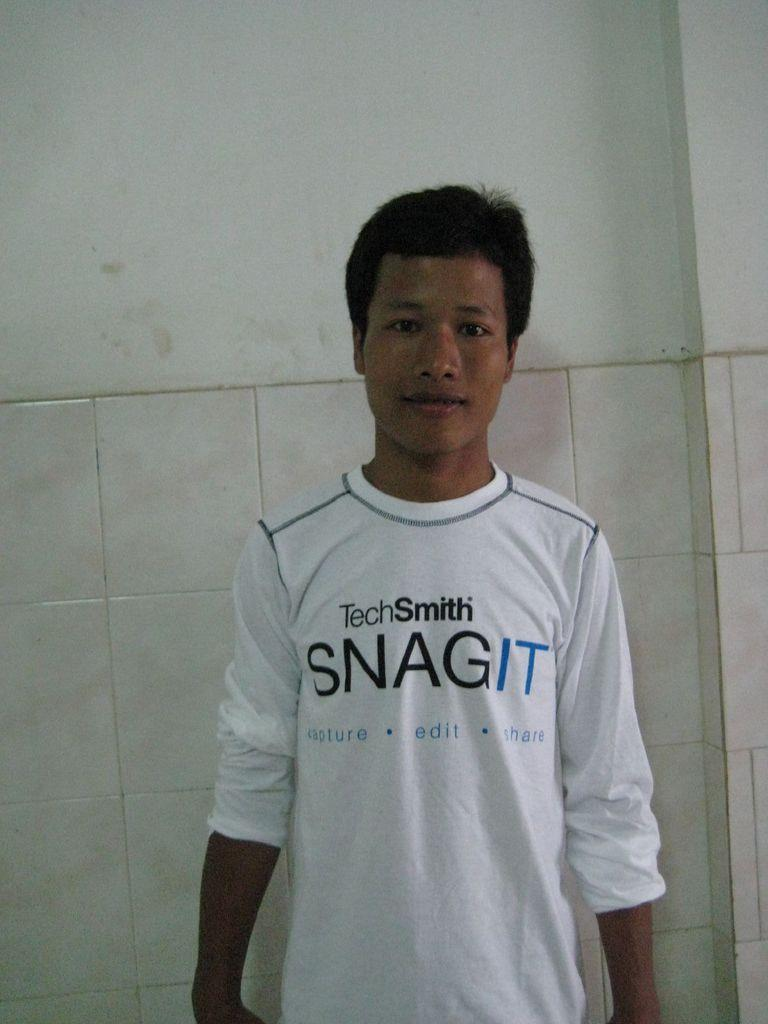What is the main subject of the image? The main subject of the image is a man. What is the man wearing in the image? The man is wearing a t-shirt. What expression does the man have in the image? The man is smiling. What can be seen in the background of the image? There is a wall in the background of the image. What type of wilderness can be seen in the image? There is no wilderness present in the image; it features a man in a t-shirt who is smiling. What type of celery dish is being prepared in the image? There is no celery or any dish being prepared in the image. 